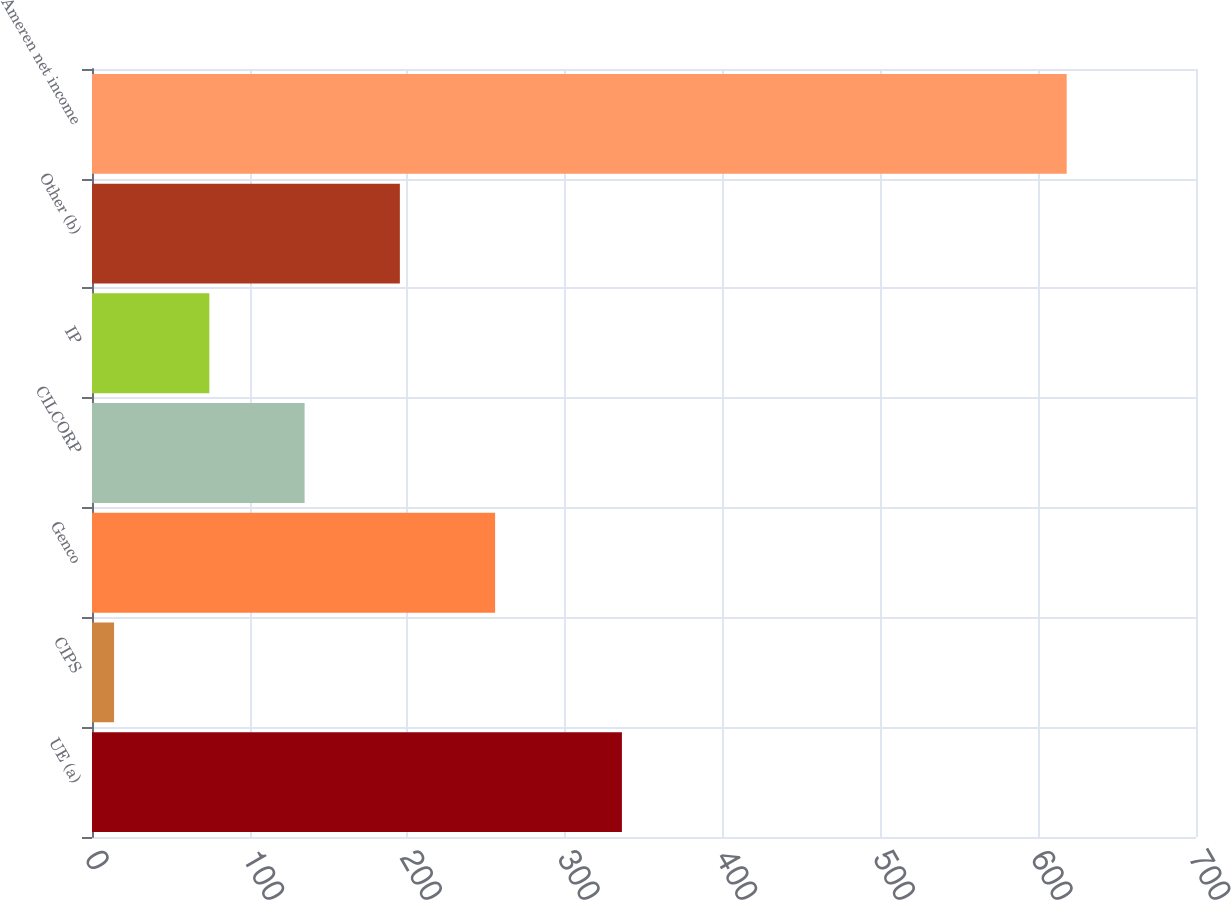Convert chart to OTSL. <chart><loc_0><loc_0><loc_500><loc_500><bar_chart><fcel>UE (a)<fcel>CIPS<fcel>Genco<fcel>CILCORP<fcel>IP<fcel>Other (b)<fcel>Ameren net income<nl><fcel>336<fcel>14<fcel>255.6<fcel>134.8<fcel>74.4<fcel>195.2<fcel>618<nl></chart> 